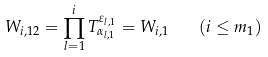Convert formula to latex. <formula><loc_0><loc_0><loc_500><loc_500>W _ { i , 1 2 } = \prod ^ { i } _ { l = 1 } T ^ { \varepsilon _ { l , 1 } } _ { \alpha _ { l , 1 } } = W _ { i , 1 } \quad ( i \leq m _ { 1 } )</formula> 